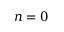<formula> <loc_0><loc_0><loc_500><loc_500>n = 0</formula> 